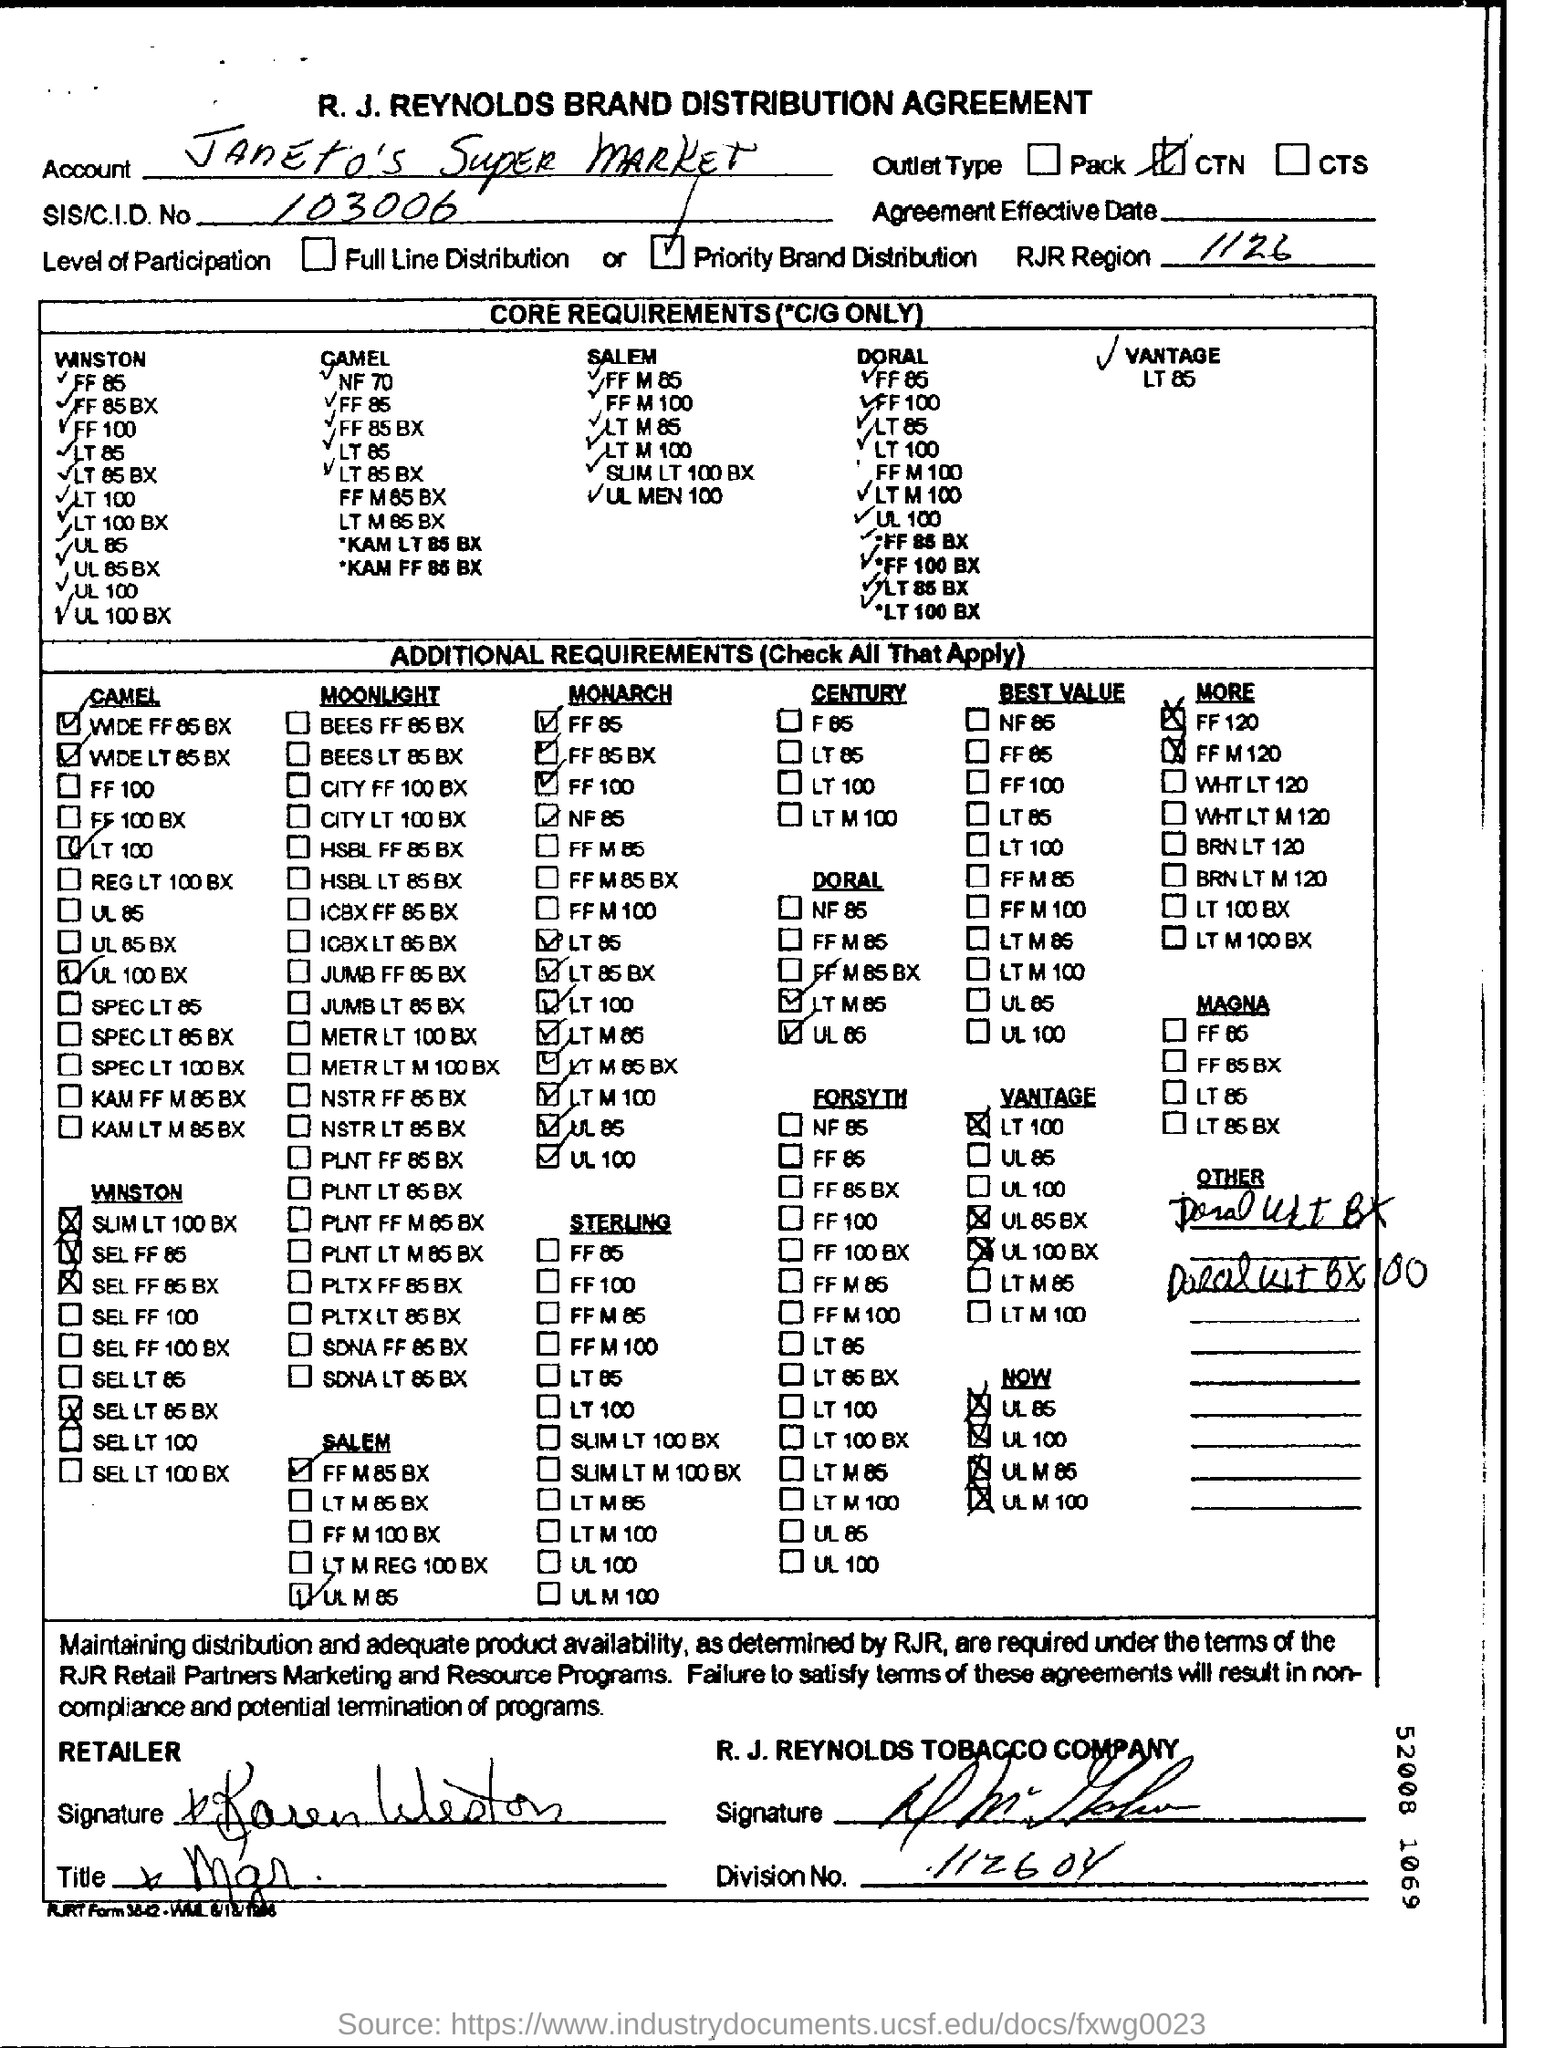Point out several critical features in this image. The account name is Janeto's Super Market. The SIS number is 103006. The letter head contains the text 'R. J. REYNOLDS BRAND DISTRIBUTION AGREEMENT.'. The RJR Region Number is 1126. The R.J. Reynolds Tobacco Company is the name of a company. 